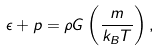<formula> <loc_0><loc_0><loc_500><loc_500>\epsilon + p = \rho G \left ( \frac { m } { k _ { B } T } \right ) ,</formula> 